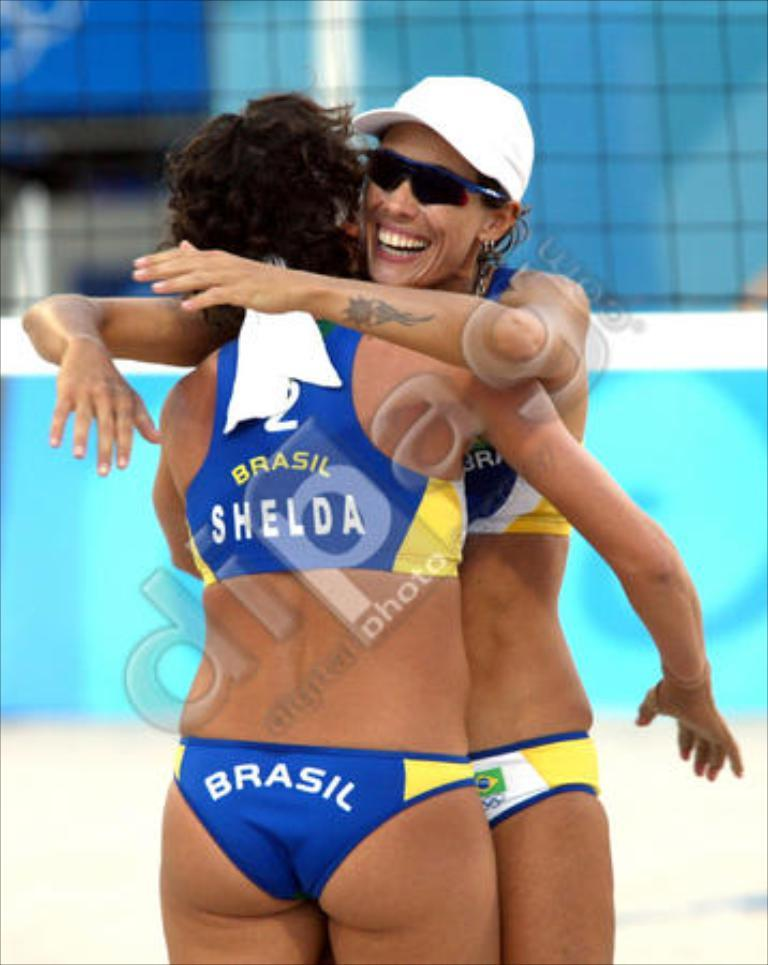How many people are in the image? There are two people in the image. What are the two people doing in the image? The two people are hugging each other. What can be seen in the background of the image? There is a banner in the background of the image. What type of architectural feature is present in the image? There are glass windows in the image. What is located at the center of the image? There is some text at the center of the image. What type of trouble is the person on the left facing in the image? There is no indication of trouble in the image; the two people are hugging each other. What is the facial expression of the person on the right in the image? There is no information about facial expressions in the image, as it only mentions that the two people are hugging each other. 